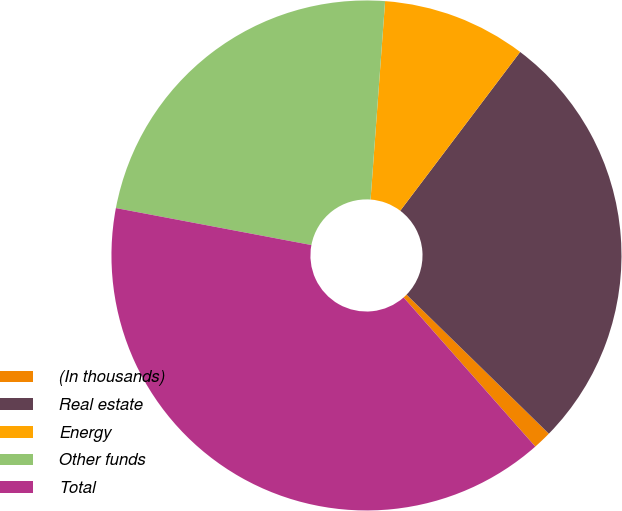<chart> <loc_0><loc_0><loc_500><loc_500><pie_chart><fcel>(In thousands)<fcel>Real estate<fcel>Energy<fcel>Other funds<fcel>Total<nl><fcel>1.17%<fcel>27.02%<fcel>9.13%<fcel>23.19%<fcel>39.49%<nl></chart> 